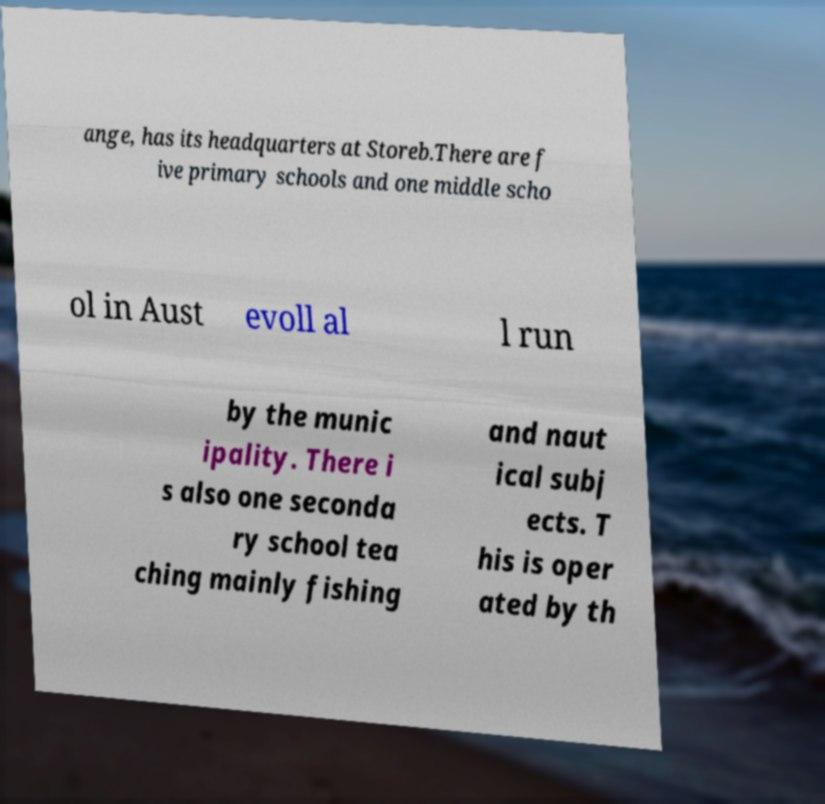Could you assist in decoding the text presented in this image and type it out clearly? ange, has its headquarters at Storeb.There are f ive primary schools and one middle scho ol in Aust evoll al l run by the munic ipality. There i s also one seconda ry school tea ching mainly fishing and naut ical subj ects. T his is oper ated by th 